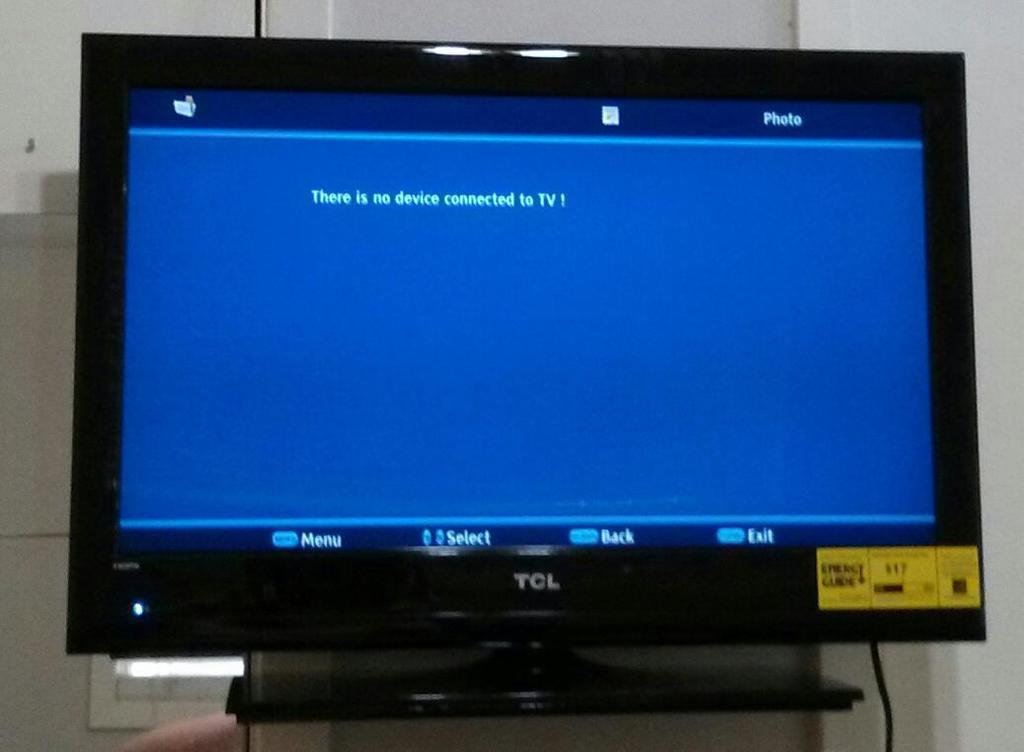What is the make of this monitor?
Make the answer very short. Tcl. What four options are displayed on the bottom of the blue screen?
Ensure brevity in your answer.  Menu, select, back, exit. 